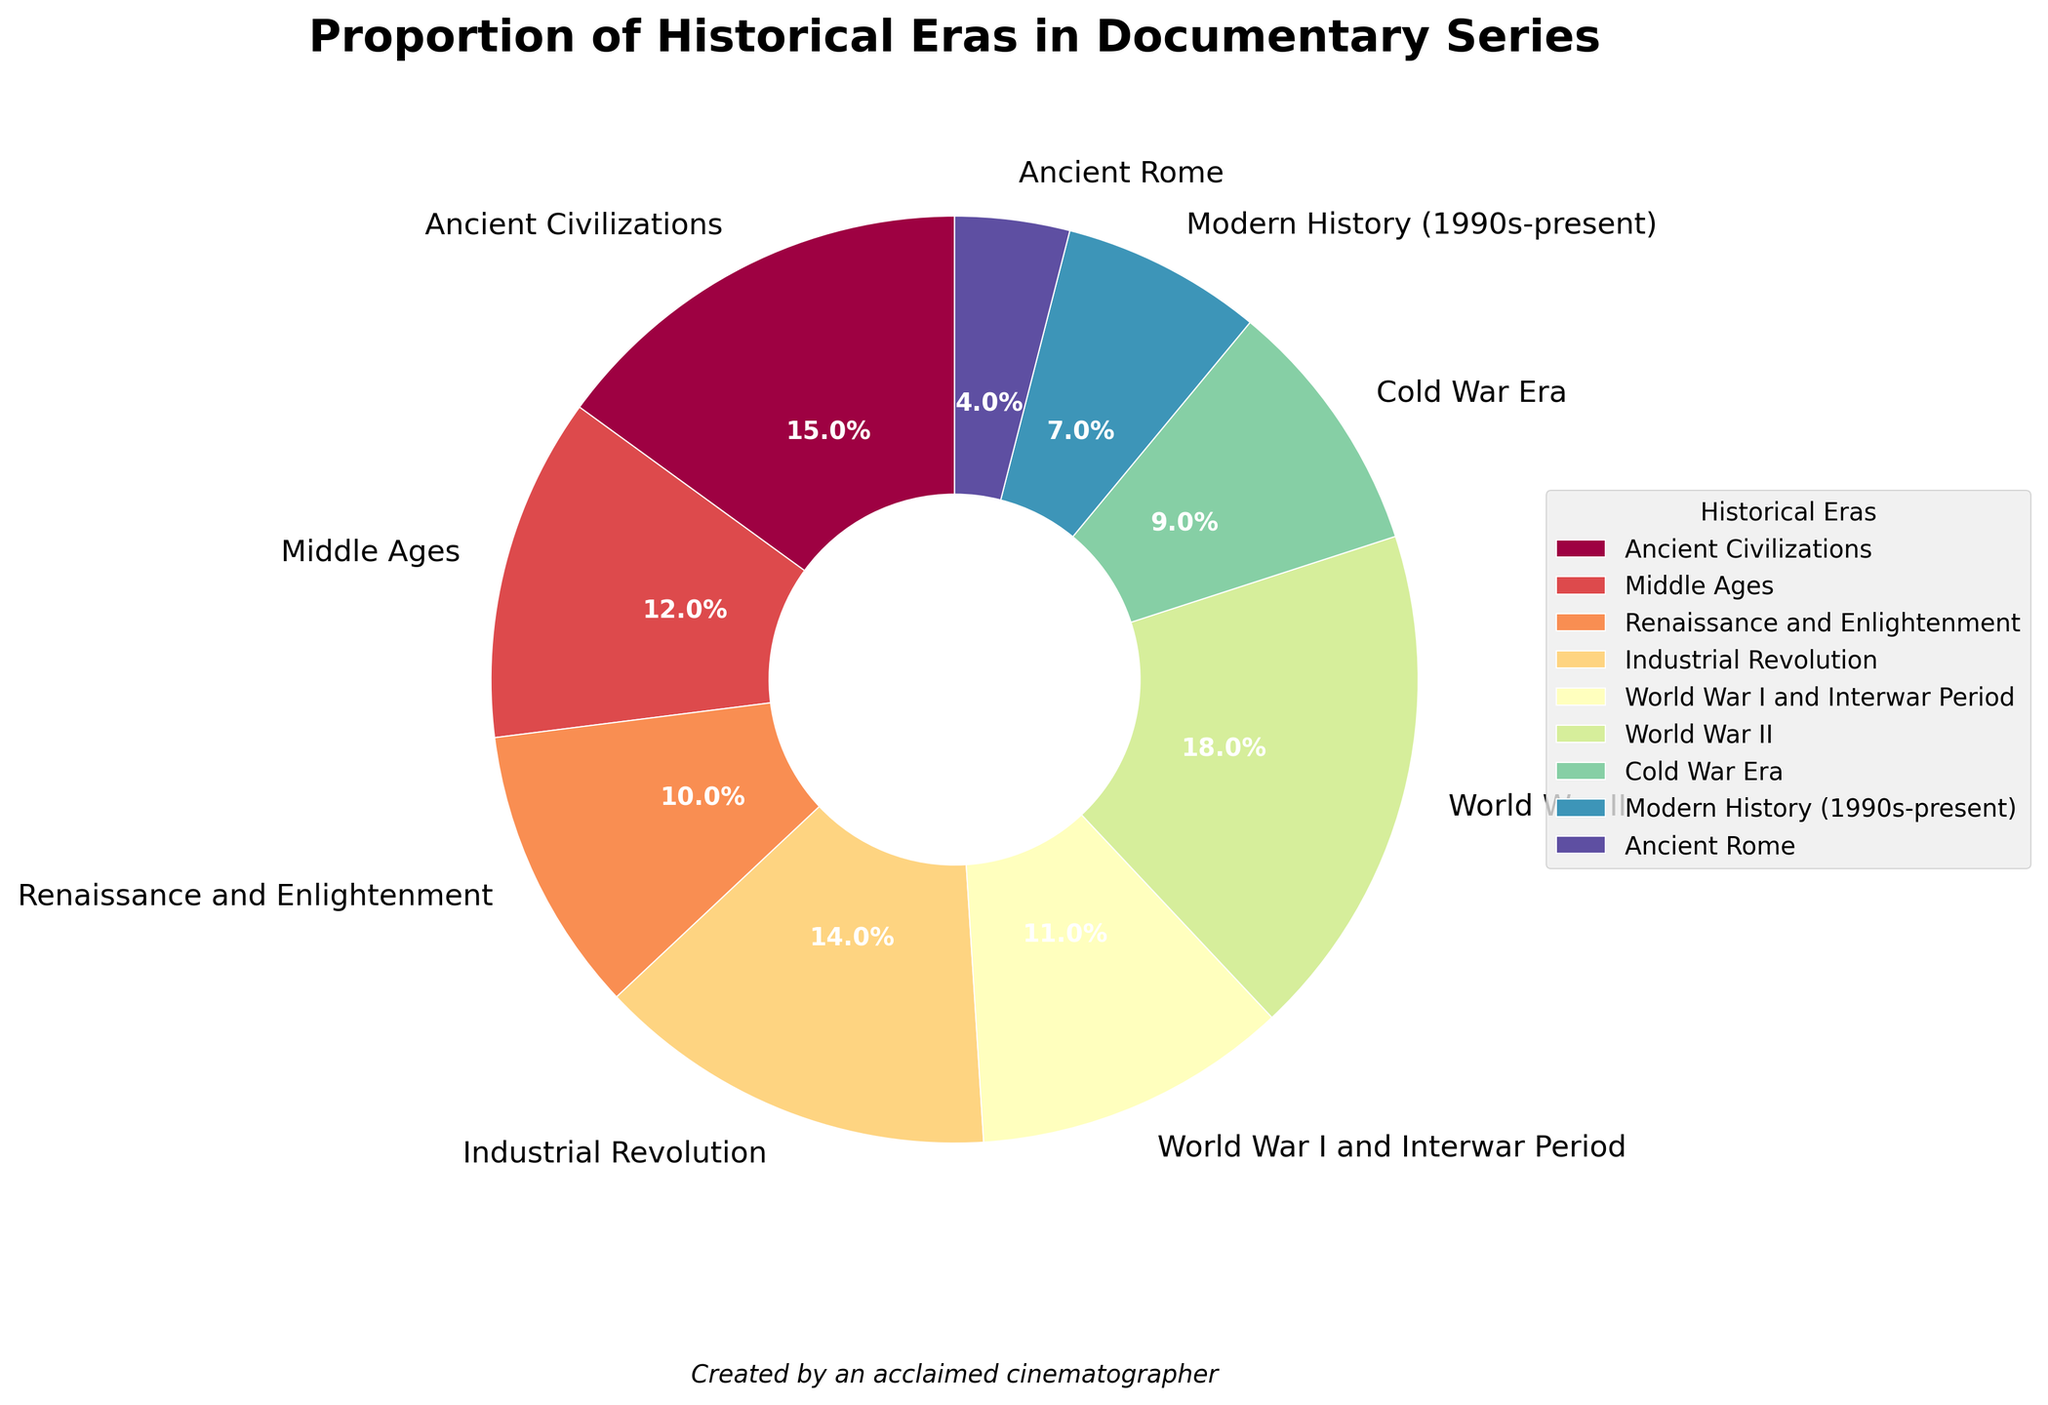what is the total percentage covered by the World Wars? Refer to the wedge labels for "World War I and Interwar Period" (11%) and "World War II" (18%). Sum these percentages to get the total. 11 + 18 = 29%
Answer: 29% Which historical era has the smallest proportion in the documentaries? Look at the wedges and their associated labels to identify the smallest one. "Ancient Rome" has the smallest percentage of 4%
Answer: Ancient Rome Which historical era has the highest percentage covered? Visually identify the largest wedge and check its label. The wedge for "World War II" is the largest at 18%
Answer: World War II What is the combined percentage for the Middle Ages and the Renaissance and Enlightenment periods? Check the wedge labels for "Middle Ages" (12%) and "Renaissance and Enlightenment" (10%). Sum these percentages: 12 + 10 = 22%
Answer: 22% Is the percentage of documentaries covering Ancient Civilizations greater than the percentage covering the Cold War Era? Compare the wedge for "Ancient Civilizations" (15%) with the wedge for "Cold War Era" (9%). Since 15 is greater than 9, the answer is yes
Answer: Yes What is the difference in percentage between the Industrial Revolution and Modern History? Find the percentages for "Industrial Revolution" (14%) and "Modern History (1990s-present)" (7%), then subtract the smaller from the larger. 14 - 7 = 7%
Answer: 7% How many historical eras have a coverage percentage greater than 10%? Identify wedges with percentages greater than 10%. These are "Ancient Civilizations" (15%), "Middle Ages" (12%), "Industrial Revolution" (14%), "World War I and Interwar Period" (11%), and "World War II" (18%). Count these eras: 5
Answer: 5 